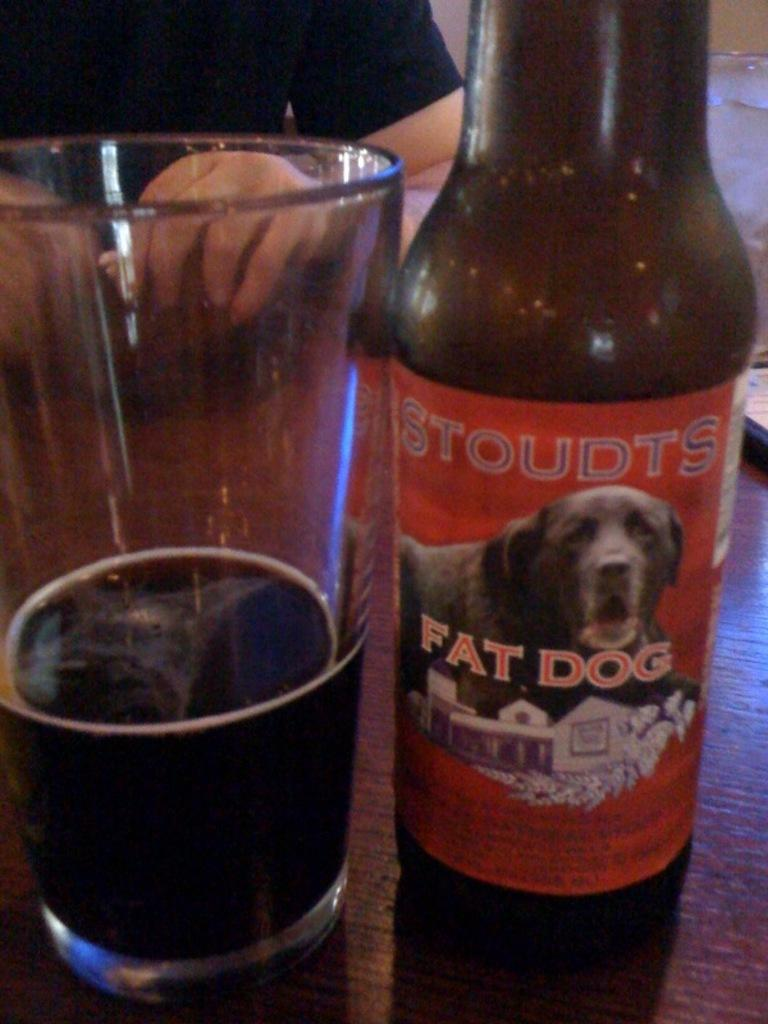<image>
Create a compact narrative representing the image presented. A bottle of Stoudts Fat Dog sits next to a partially full glass. 